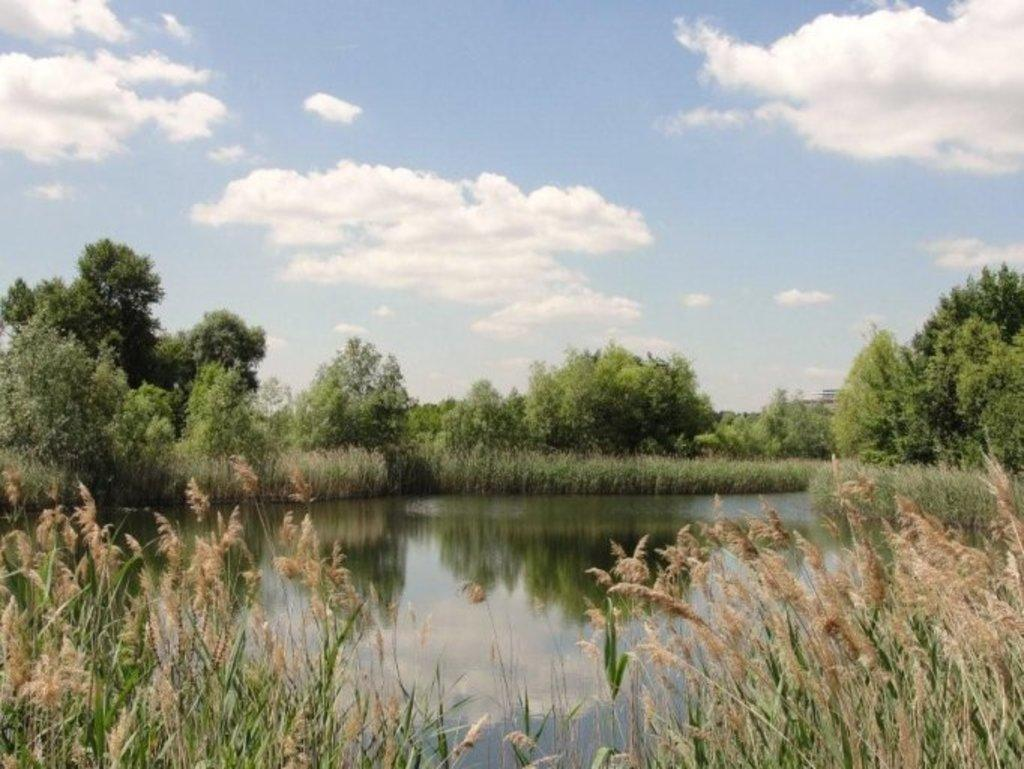What type of vegetation is present in the image? There is grass in the image. What can be seen in the middle of the image? There is a pond in the middle of the image. What is visible in the background of the image? There are trees and the sky visible in the background of the image. How many girls are participating in the week-long event in the image? There are no girls or events present in the image; it features a grassy area with a pond and trees in the background. 